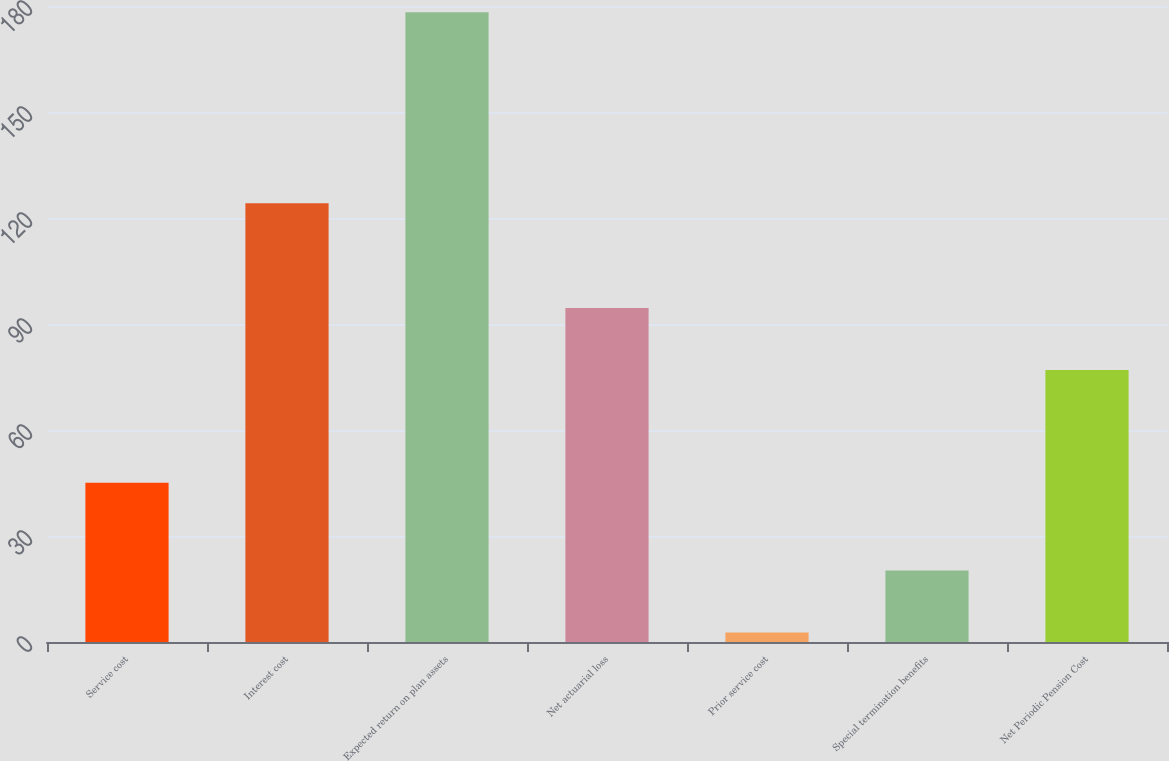Convert chart to OTSL. <chart><loc_0><loc_0><loc_500><loc_500><bar_chart><fcel>Service cost<fcel>Interest cost<fcel>Expected return on plan assets<fcel>Net actuarial loss<fcel>Prior service cost<fcel>Special termination benefits<fcel>Net Periodic Pension Cost<nl><fcel>45.1<fcel>124.2<fcel>178.2<fcel>94.55<fcel>2.7<fcel>20.25<fcel>77<nl></chart> 